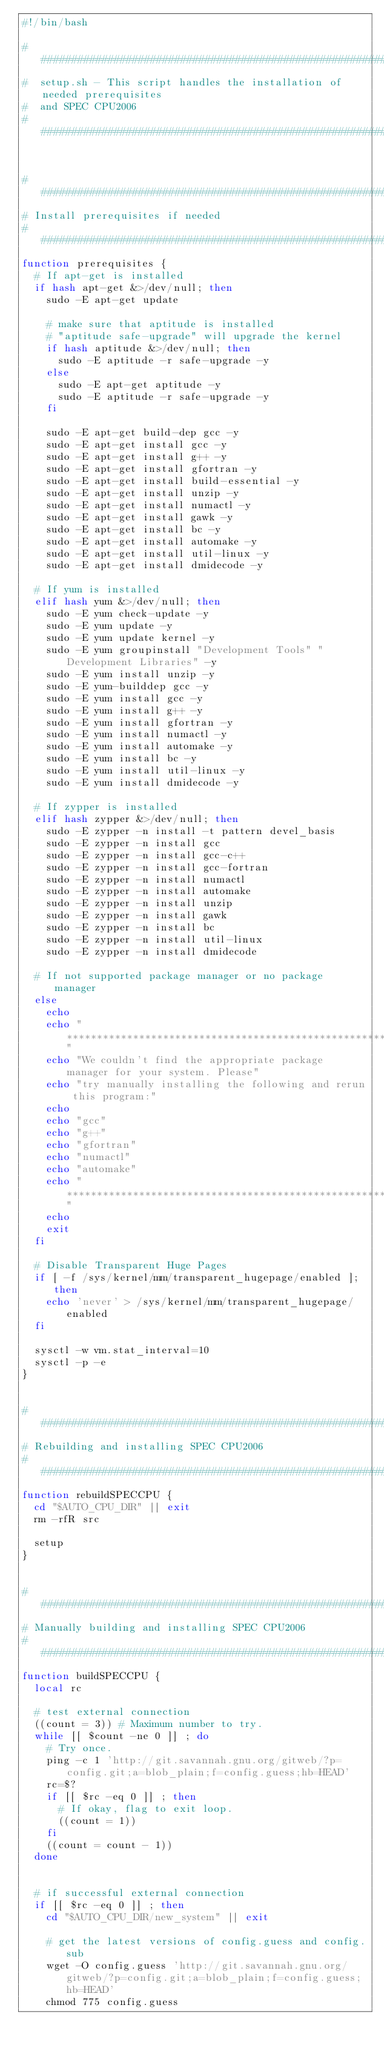Convert code to text. <code><loc_0><loc_0><loc_500><loc_500><_Bash_>#!/bin/bash

##############################################################################
#  setup.sh - This script handles the installation of needed prerequisites
#  and SPEC CPU2006
##############################################################################


############################################################
# Install prerequisites if needed
############################################################
function prerequisites {
  # If apt-get is installed
  if hash apt-get &>/dev/null; then
    sudo -E apt-get update

    # make sure that aptitude is installed
    # "aptitude safe-upgrade" will upgrade the kernel
    if hash aptitude &>/dev/null; then
      sudo -E aptitude -r safe-upgrade -y
    else
      sudo -E apt-get aptitude -y
      sudo -E aptitude -r safe-upgrade -y
    fi

    sudo -E apt-get build-dep gcc -y
    sudo -E apt-get install gcc -y
    sudo -E apt-get install g++ -y
    sudo -E apt-get install gfortran -y
    sudo -E apt-get install build-essential -y
    sudo -E apt-get install unzip -y
    sudo -E apt-get install numactl -y
    sudo -E apt-get install gawk -y
    sudo -E apt-get install bc -y
    sudo -E apt-get install automake -y
    sudo -E apt-get install util-linux -y
    sudo -E apt-get install dmidecode -y

  # If yum is installed
  elif hash yum &>/dev/null; then
    sudo -E yum check-update -y
    sudo -E yum update -y
    sudo -E yum update kernel -y
    sudo -E yum groupinstall "Development Tools" "Development Libraries" -y
    sudo -E yum install unzip -y
    sudo -E yum-builddep gcc -y
    sudo -E yum install gcc -y
    sudo -E yum install g++ -y
    sudo -E yum install gfortran -y
    sudo -E yum install numactl -y
    sudo -E yum install automake -y
    sudo -E yum install bc -y
    sudo -E yum install util-linux -y
    sudo -E yum install dmidecode -y

  # If zypper is installed
  elif hash zypper &>/dev/null; then
    sudo -E zypper -n install -t pattern devel_basis
    sudo -E zypper -n install gcc
    sudo -E zypper -n install gcc-c++
    sudo -E zypper -n install gcc-fortran
    sudo -E zypper -n install numactl
    sudo -E zypper -n install automake
    sudo -E zypper -n install unzip
    sudo -E zypper -n install gawk
    sudo -E zypper -n install bc
    sudo -E zypper -n install util-linux
    sudo -E zypper -n install dmidecode

  # If not supported package manager or no package manager
  else
    echo
    echo "*************************************************************************"
    echo "We couldn't find the appropriate package manager for your system. Please"
    echo "try manually installing the following and rerun this program:"
    echo
    echo "gcc"
    echo "g++"
    echo "gfortran"
    echo "numactl"
    echo "automake"
    echo "*************************************************************************"
    echo
    exit
  fi

  # Disable Transparent Huge Pages
  if [ -f /sys/kernel/mm/transparent_hugepage/enabled ]; then
    echo 'never' > /sys/kernel/mm/transparent_hugepage/enabled
  fi

  sysctl -w vm.stat_interval=10
  sysctl -p -e
}


############################################################
# Rebuilding and installing SPEC CPU2006
############################################################
function rebuildSPECCPU {
  cd "$AUTO_CPU_DIR" || exit
  rm -rfR src

  setup
}


############################################################
# Manually building and installing SPEC CPU2006
############################################################
function buildSPECCPU {
  local rc

  # test external connection
  ((count = 3)) # Maximum number to try.
  while [[ $count -ne 0 ]] ; do
    # Try once.
    ping -c 1 'http://git.savannah.gnu.org/gitweb/?p=config.git;a=blob_plain;f=config.guess;hb=HEAD'
    rc=$?
    if [[ $rc -eq 0 ]] ; then
      # If okay, flag to exit loop.
      ((count = 1))
    fi
    ((count = count - 1))
  done


  # if successful external connection
  if [[ $rc -eq 0 ]] ; then
    cd "$AUTO_CPU_DIR/new_system" || exit

    # get the latest versions of config.guess and config.sub
    wget -O config.guess 'http://git.savannah.gnu.org/gitweb/?p=config.git;a=blob_plain;f=config.guess;hb=HEAD'
    chmod 775 config.guess</code> 